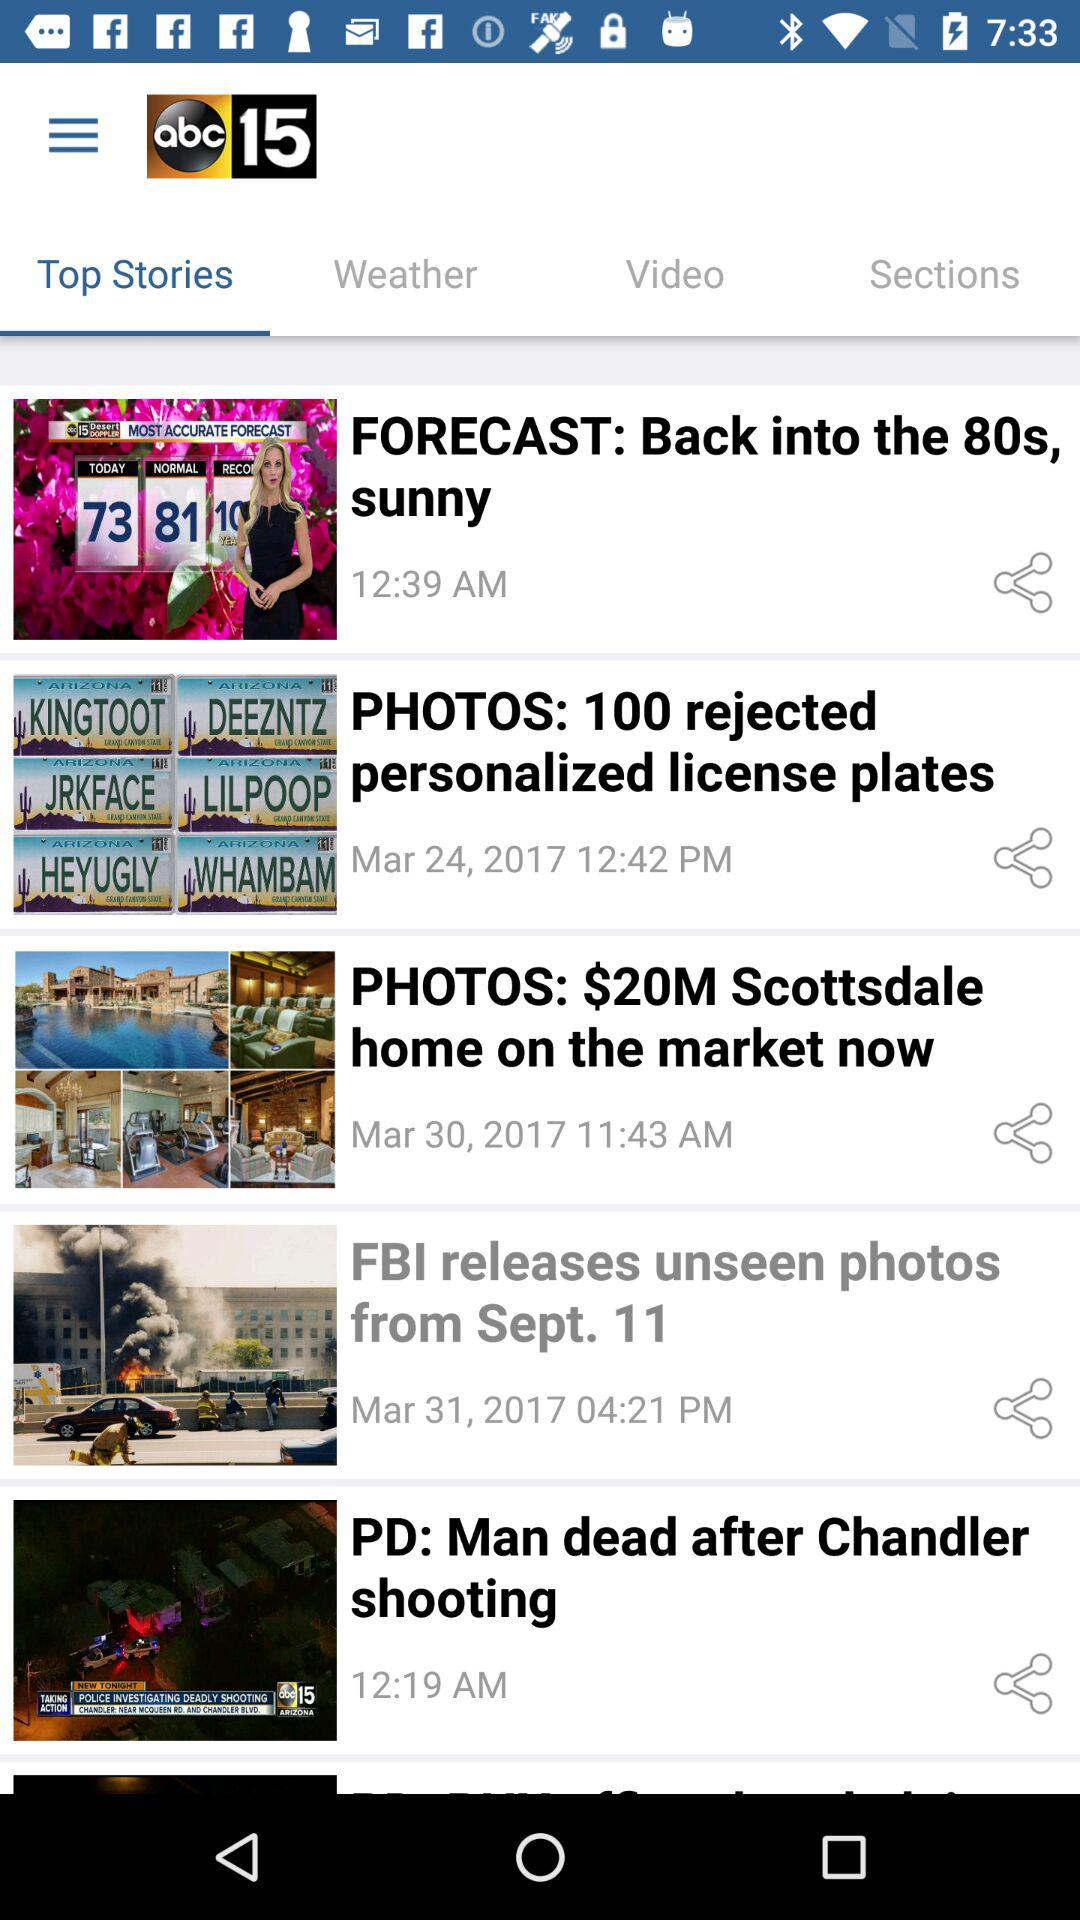What story is post on march 24, 2017? The story is "PHOTOS: 100 rejected personalized license plates". 